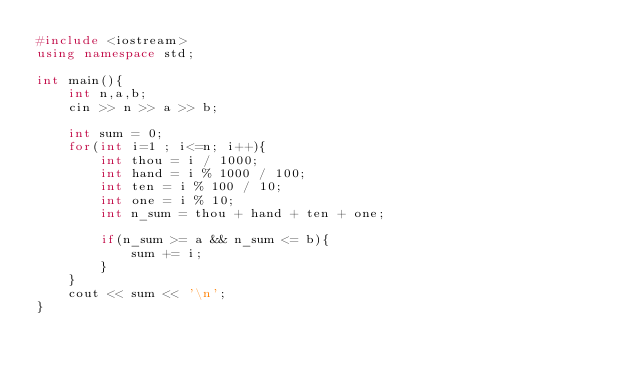Convert code to text. <code><loc_0><loc_0><loc_500><loc_500><_C++_>#include <iostream>
using namespace std;

int main(){
    int n,a,b;
    cin >> n >> a >> b;

    int sum = 0;
    for(int i=1 ; i<=n; i++){
        int thou = i / 1000;
        int hand = i % 1000 / 100;
        int ten = i % 100 / 10;
        int one = i % 10; 
        int n_sum = thou + hand + ten + one;

        if(n_sum >= a && n_sum <= b){
            sum += i;
        }
    }
    cout << sum << '\n';
}</code> 